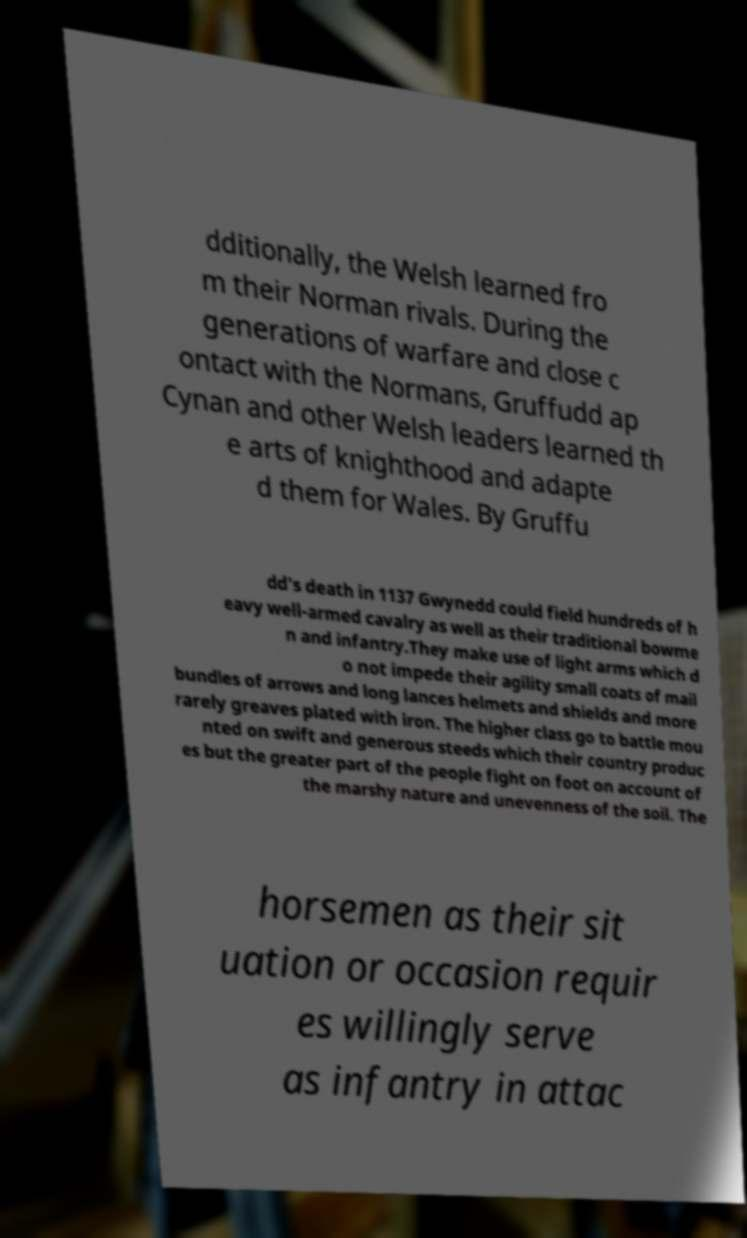Please identify and transcribe the text found in this image. dditionally, the Welsh learned fro m their Norman rivals. During the generations of warfare and close c ontact with the Normans, Gruffudd ap Cynan and other Welsh leaders learned th e arts of knighthood and adapte d them for Wales. By Gruffu dd's death in 1137 Gwynedd could field hundreds of h eavy well-armed cavalry as well as their traditional bowme n and infantry.They make use of light arms which d o not impede their agility small coats of mail bundles of arrows and long lances helmets and shields and more rarely greaves plated with iron. The higher class go to battle mou nted on swift and generous steeds which their country produc es but the greater part of the people fight on foot on account of the marshy nature and unevenness of the soil. The horsemen as their sit uation or occasion requir es willingly serve as infantry in attac 